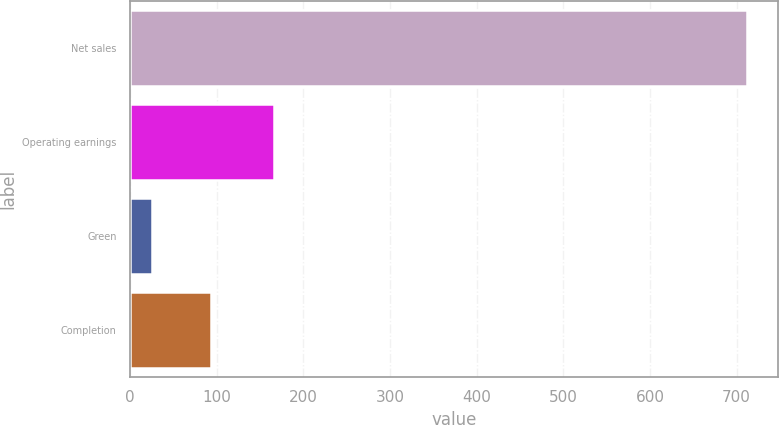Convert chart to OTSL. <chart><loc_0><loc_0><loc_500><loc_500><bar_chart><fcel>Net sales<fcel>Operating earnings<fcel>Green<fcel>Completion<nl><fcel>712<fcel>166<fcel>25<fcel>93.7<nl></chart> 